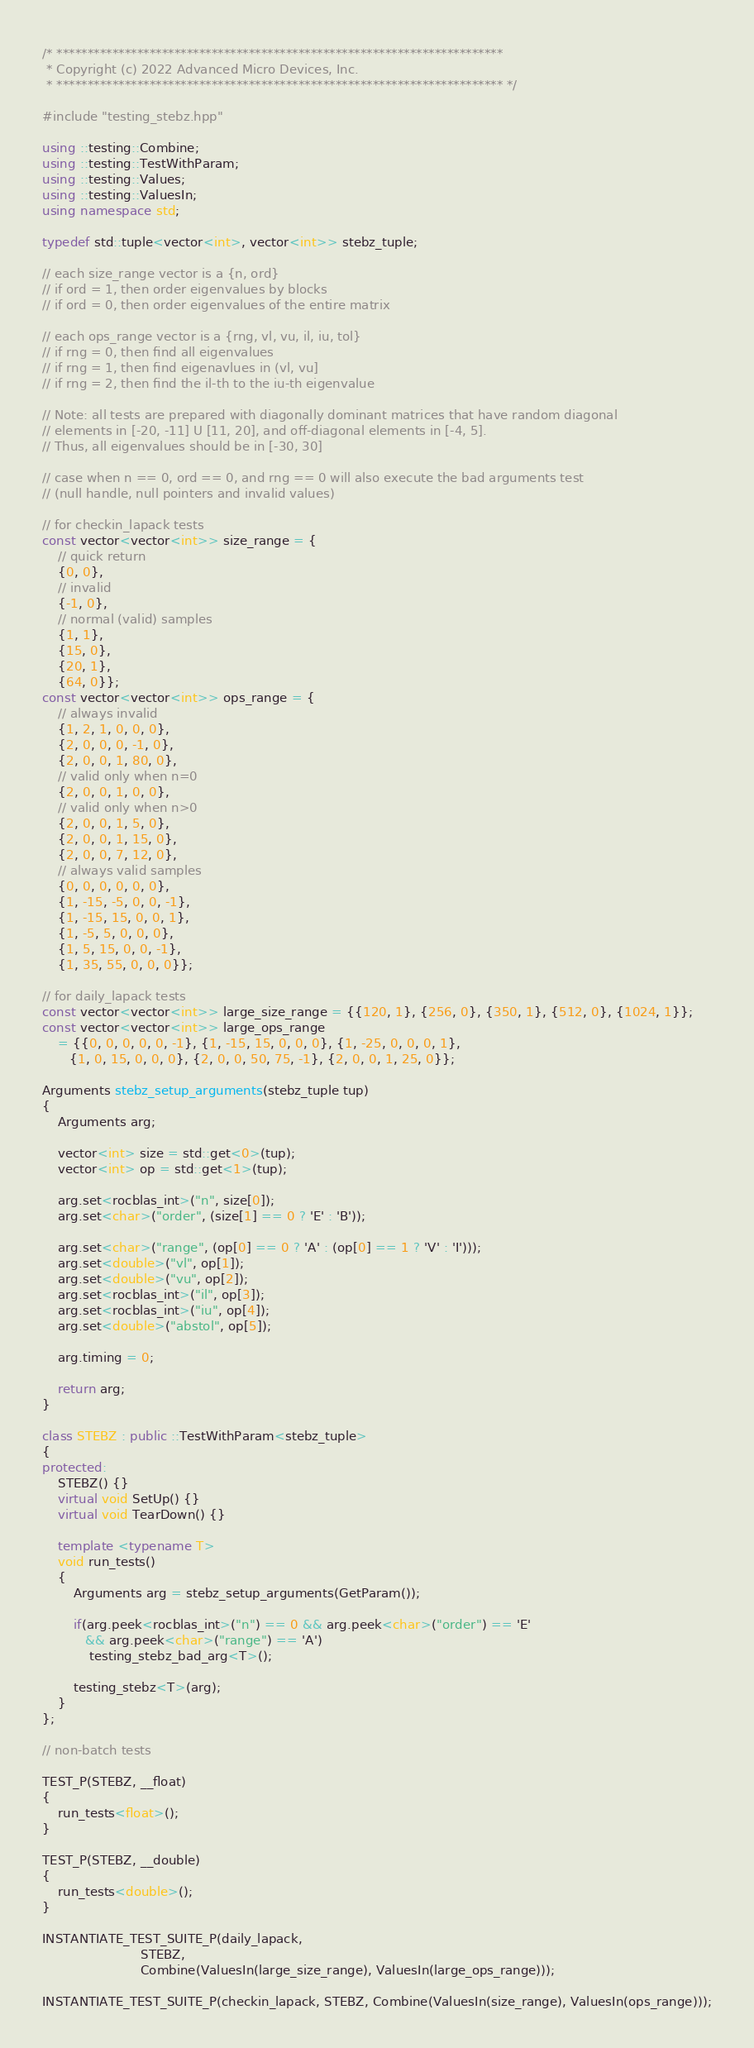<code> <loc_0><loc_0><loc_500><loc_500><_C++_>/* ************************************************************************
 * Copyright (c) 2022 Advanced Micro Devices, Inc.
 * ************************************************************************ */

#include "testing_stebz.hpp"

using ::testing::Combine;
using ::testing::TestWithParam;
using ::testing::Values;
using ::testing::ValuesIn;
using namespace std;

typedef std::tuple<vector<int>, vector<int>> stebz_tuple;

// each size_range vector is a {n, ord}
// if ord = 1, then order eigenvalues by blocks
// if ord = 0, then order eigenvalues of the entire matrix

// each ops_range vector is a {rng, vl, vu, il, iu, tol}
// if rng = 0, then find all eigenvalues
// if rng = 1, then find eigenavlues in (vl, vu]
// if rng = 2, then find the il-th to the iu-th eigenvalue

// Note: all tests are prepared with diagonally dominant matrices that have random diagonal
// elements in [-20, -11] U [11, 20], and off-diagonal elements in [-4, 5].
// Thus, all eigenvalues should be in [-30, 30]

// case when n == 0, ord == 0, and rng == 0 will also execute the bad arguments test
// (null handle, null pointers and invalid values)

// for checkin_lapack tests
const vector<vector<int>> size_range = {
    // quick return
    {0, 0},
    // invalid
    {-1, 0},
    // normal (valid) samples
    {1, 1},
    {15, 0},
    {20, 1},
    {64, 0}};
const vector<vector<int>> ops_range = {
    // always invalid
    {1, 2, 1, 0, 0, 0},
    {2, 0, 0, 0, -1, 0},
    {2, 0, 0, 1, 80, 0},
    // valid only when n=0
    {2, 0, 0, 1, 0, 0},
    // valid only when n>0
    {2, 0, 0, 1, 5, 0},
    {2, 0, 0, 1, 15, 0},
    {2, 0, 0, 7, 12, 0},
    // always valid samples
    {0, 0, 0, 0, 0, 0},
    {1, -15, -5, 0, 0, -1},
    {1, -15, 15, 0, 0, 1},
    {1, -5, 5, 0, 0, 0},
    {1, 5, 15, 0, 0, -1},
    {1, 35, 55, 0, 0, 0}};

// for daily_lapack tests
const vector<vector<int>> large_size_range = {{120, 1}, {256, 0}, {350, 1}, {512, 0}, {1024, 1}};
const vector<vector<int>> large_ops_range
    = {{0, 0, 0, 0, 0, -1}, {1, -15, 15, 0, 0, 0}, {1, -25, 0, 0, 0, 1},
       {1, 0, 15, 0, 0, 0}, {2, 0, 0, 50, 75, -1}, {2, 0, 0, 1, 25, 0}};

Arguments stebz_setup_arguments(stebz_tuple tup)
{
    Arguments arg;

    vector<int> size = std::get<0>(tup);
    vector<int> op = std::get<1>(tup);

    arg.set<rocblas_int>("n", size[0]);
    arg.set<char>("order", (size[1] == 0 ? 'E' : 'B'));

    arg.set<char>("range", (op[0] == 0 ? 'A' : (op[0] == 1 ? 'V' : 'I')));
    arg.set<double>("vl", op[1]);
    arg.set<double>("vu", op[2]);
    arg.set<rocblas_int>("il", op[3]);
    arg.set<rocblas_int>("iu", op[4]);
    arg.set<double>("abstol", op[5]);

    arg.timing = 0;

    return arg;
}

class STEBZ : public ::TestWithParam<stebz_tuple>
{
protected:
    STEBZ() {}
    virtual void SetUp() {}
    virtual void TearDown() {}

    template <typename T>
    void run_tests()
    {
        Arguments arg = stebz_setup_arguments(GetParam());

        if(arg.peek<rocblas_int>("n") == 0 && arg.peek<char>("order") == 'E'
           && arg.peek<char>("range") == 'A')
            testing_stebz_bad_arg<T>();

        testing_stebz<T>(arg);
    }
};

// non-batch tests

TEST_P(STEBZ, __float)
{
    run_tests<float>();
}

TEST_P(STEBZ, __double)
{
    run_tests<double>();
}

INSTANTIATE_TEST_SUITE_P(daily_lapack,
                         STEBZ,
                         Combine(ValuesIn(large_size_range), ValuesIn(large_ops_range)));

INSTANTIATE_TEST_SUITE_P(checkin_lapack, STEBZ, Combine(ValuesIn(size_range), ValuesIn(ops_range)));
</code> 